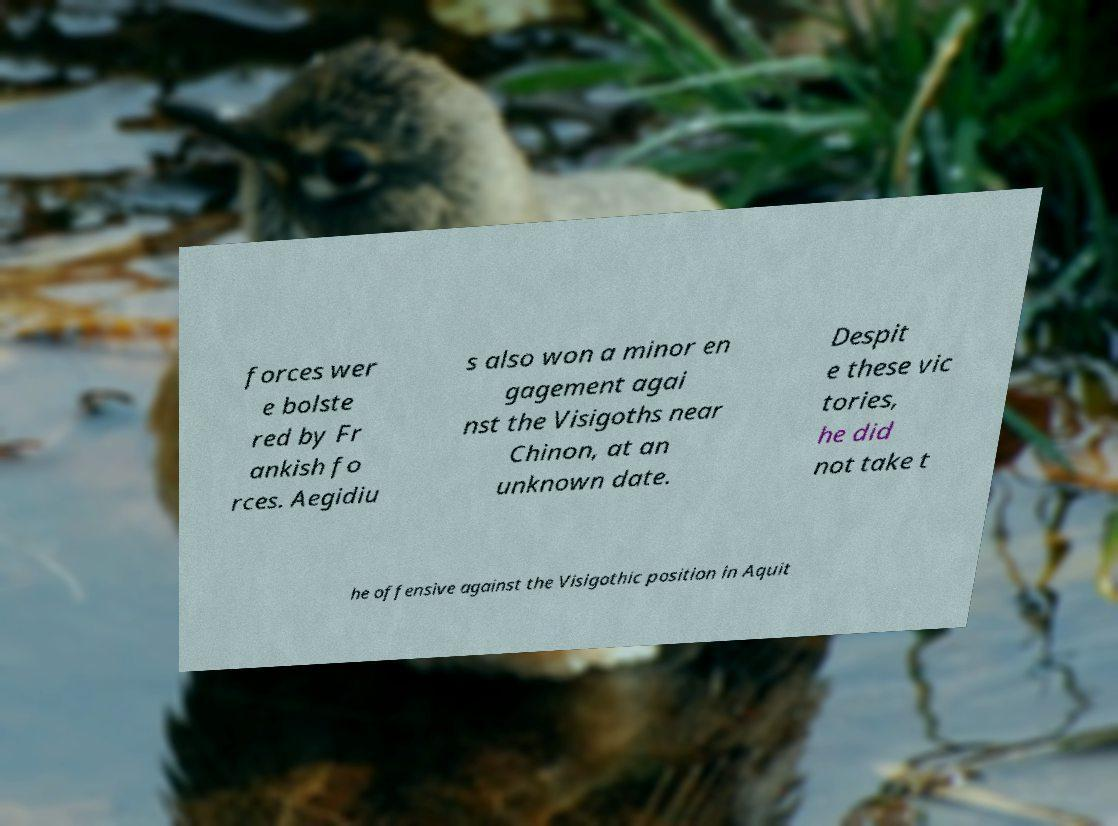Please identify and transcribe the text found in this image. forces wer e bolste red by Fr ankish fo rces. Aegidiu s also won a minor en gagement agai nst the Visigoths near Chinon, at an unknown date. Despit e these vic tories, he did not take t he offensive against the Visigothic position in Aquit 